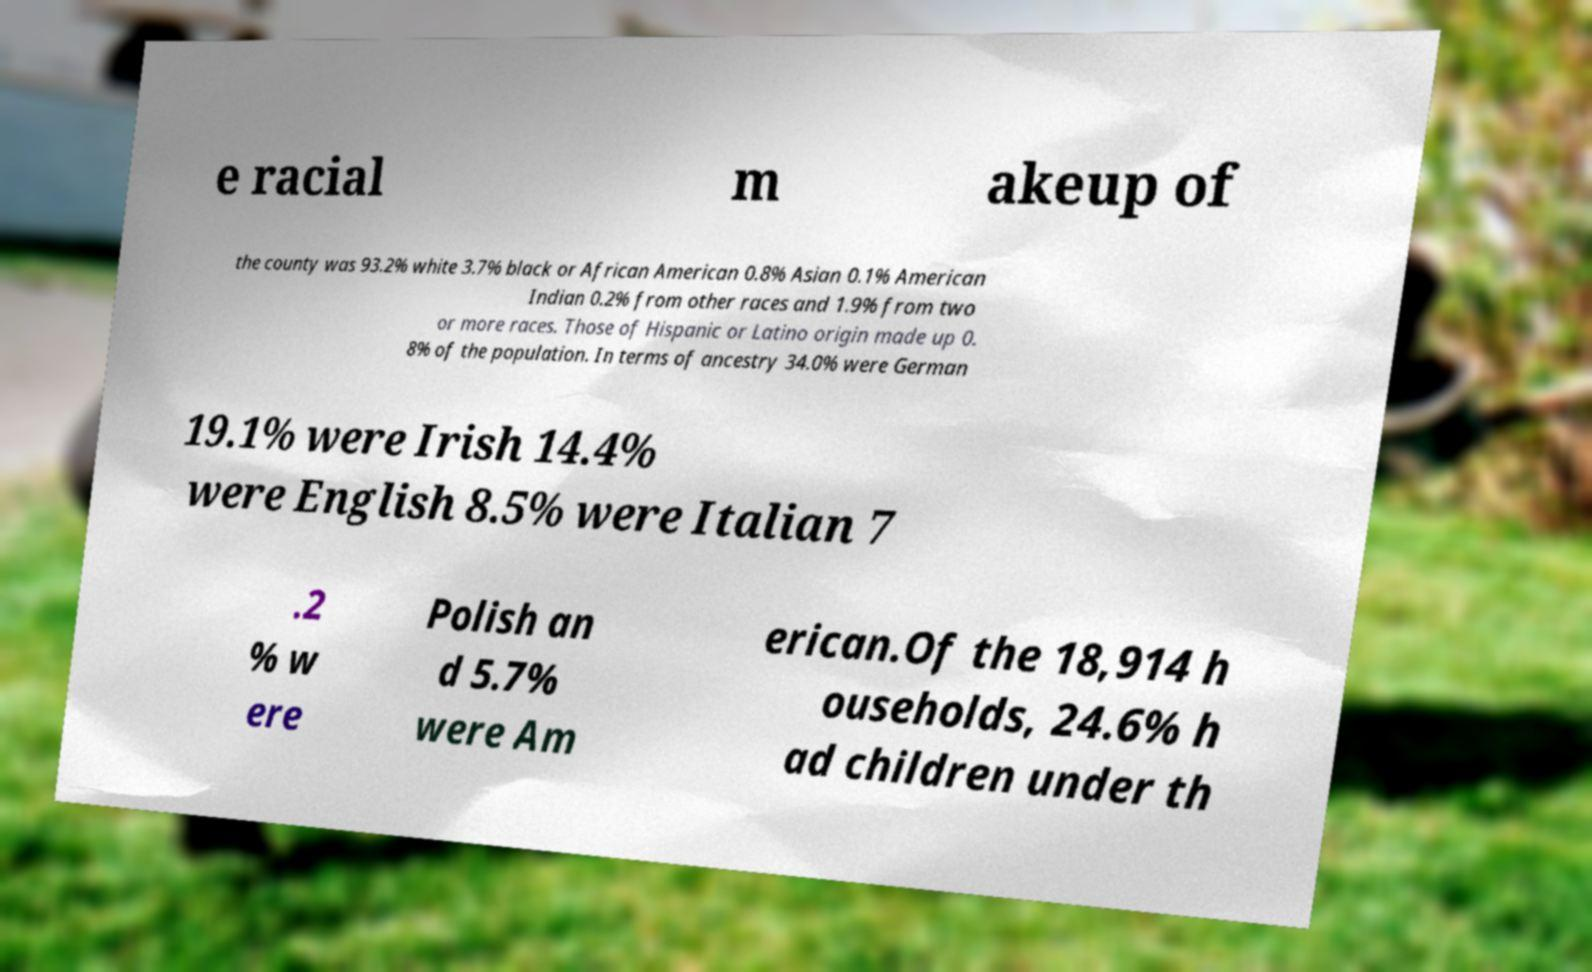What messages or text are displayed in this image? I need them in a readable, typed format. e racial m akeup of the county was 93.2% white 3.7% black or African American 0.8% Asian 0.1% American Indian 0.2% from other races and 1.9% from two or more races. Those of Hispanic or Latino origin made up 0. 8% of the population. In terms of ancestry 34.0% were German 19.1% were Irish 14.4% were English 8.5% were Italian 7 .2 % w ere Polish an d 5.7% were Am erican.Of the 18,914 h ouseholds, 24.6% h ad children under th 